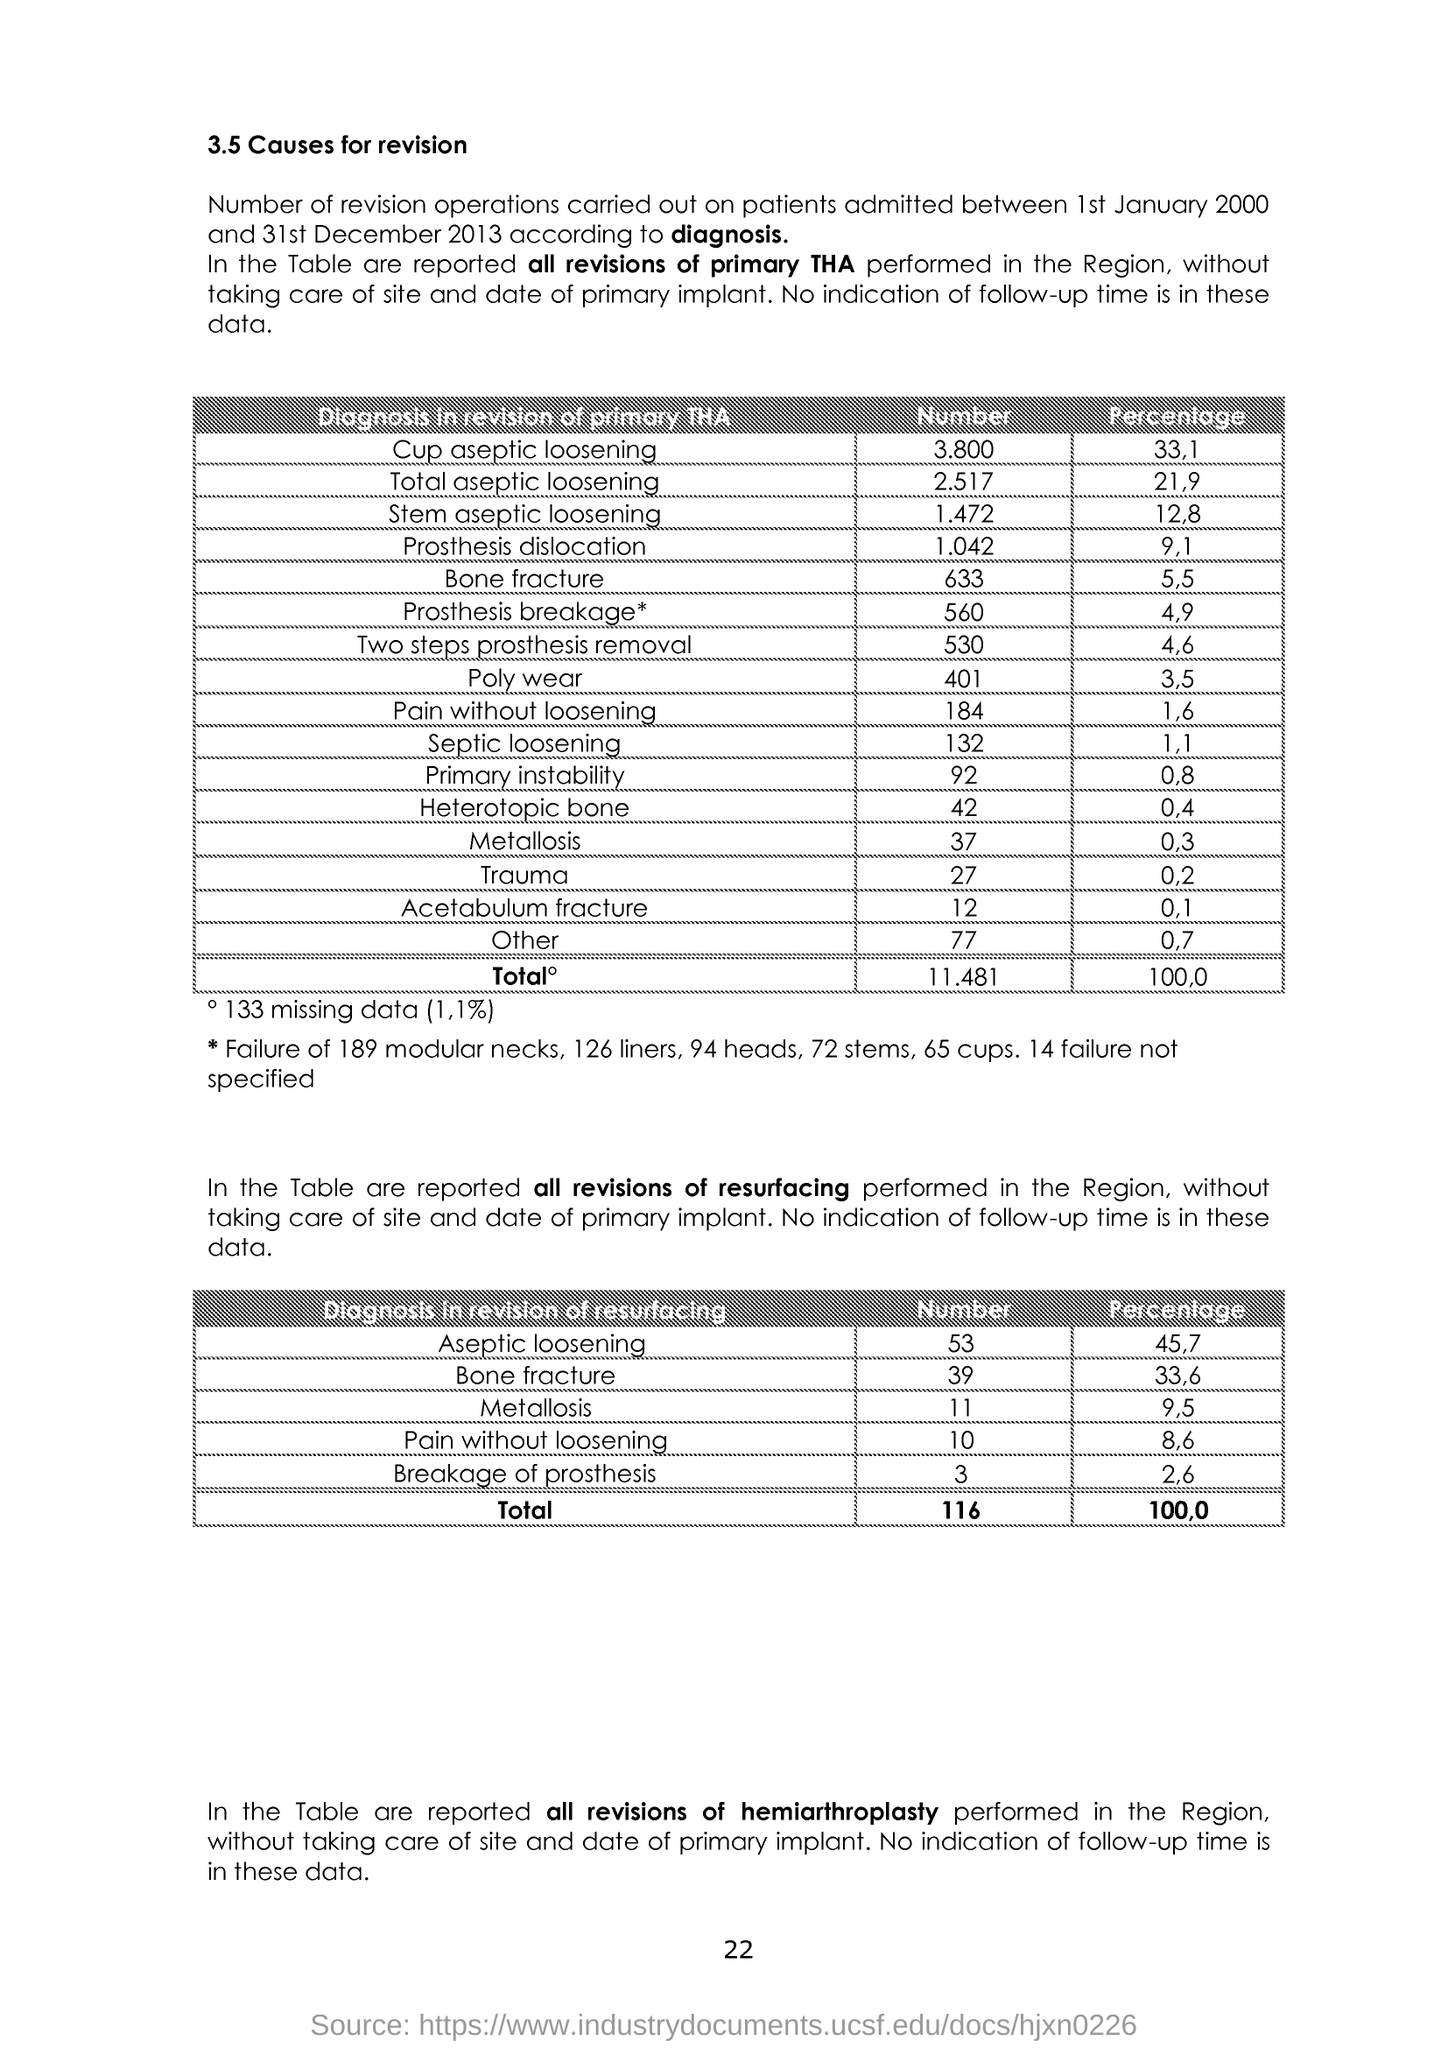What is the number of Poly wear?
Keep it short and to the point. 401. What is the Percentage of Trauma?
Keep it short and to the point. 0.2. 